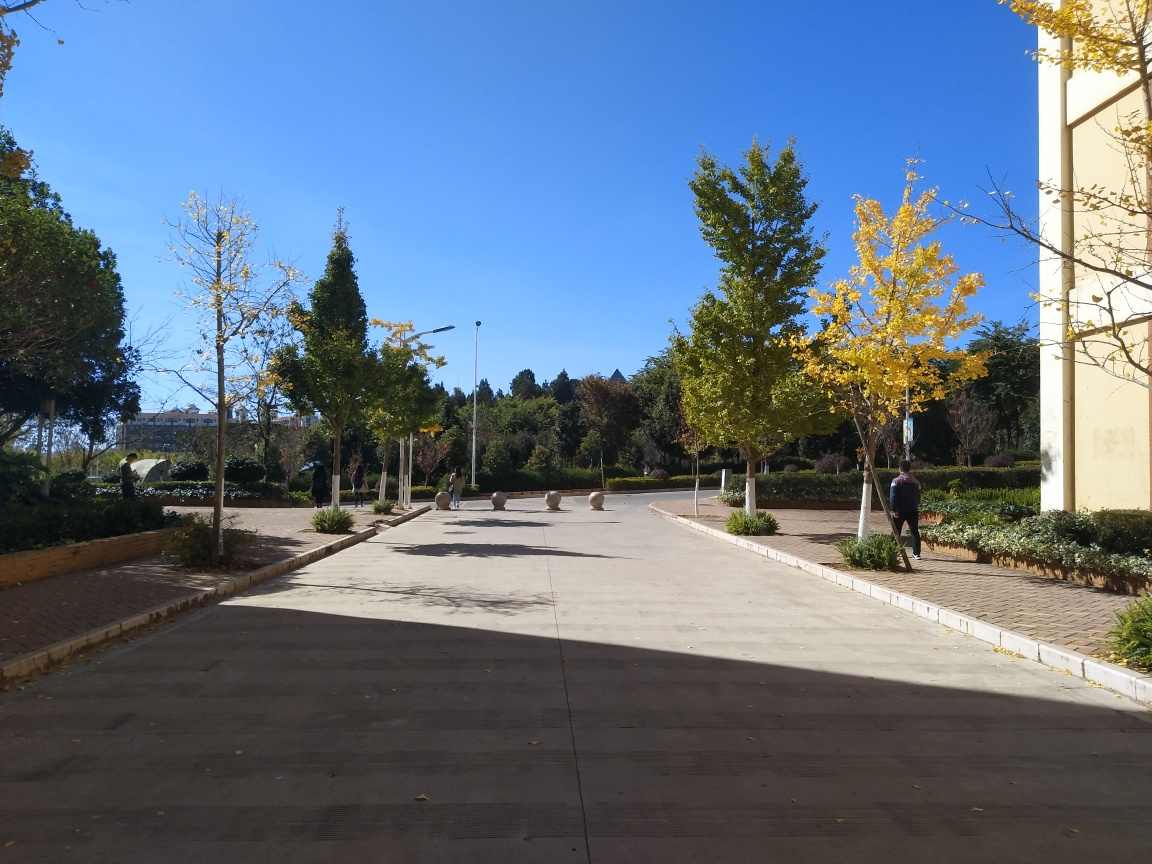Does this place seem to be frequently visited? This image portrays a tranquil setting with a few people strolling around, implying it may be a calm day or a less crowded time. The ample pathways and benches suggest it's a place designed for visitors, though it's not overly busy at this moment. What might be the purpose of this location? Judging by the careful landscaping, the arrangement of benches, and the tidy, wide pathways, this location seems to be a park or a communal outdoor area meant for leisure activities, relaxing, and enjoying the outdoors. 